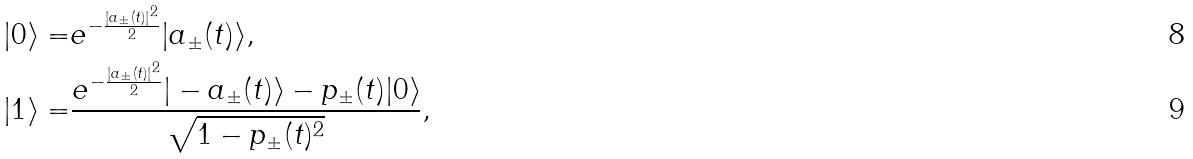Convert formula to latex. <formula><loc_0><loc_0><loc_500><loc_500>| 0 \rangle = & e ^ { - \frac { \left | a _ { \pm } ( t ) \right | ^ { 2 } } { 2 } } | a _ { \pm } ( t ) \rangle , \\ | 1 \rangle = & \frac { e ^ { - \frac { \left | a _ { \pm } ( t ) \right | ^ { 2 } } { 2 } } | - a _ { \pm } ( t ) \rangle - p _ { \pm } ( t ) | 0 \rangle } { \sqrt { 1 - p _ { \pm } ( t ) ^ { 2 } } } ,</formula> 